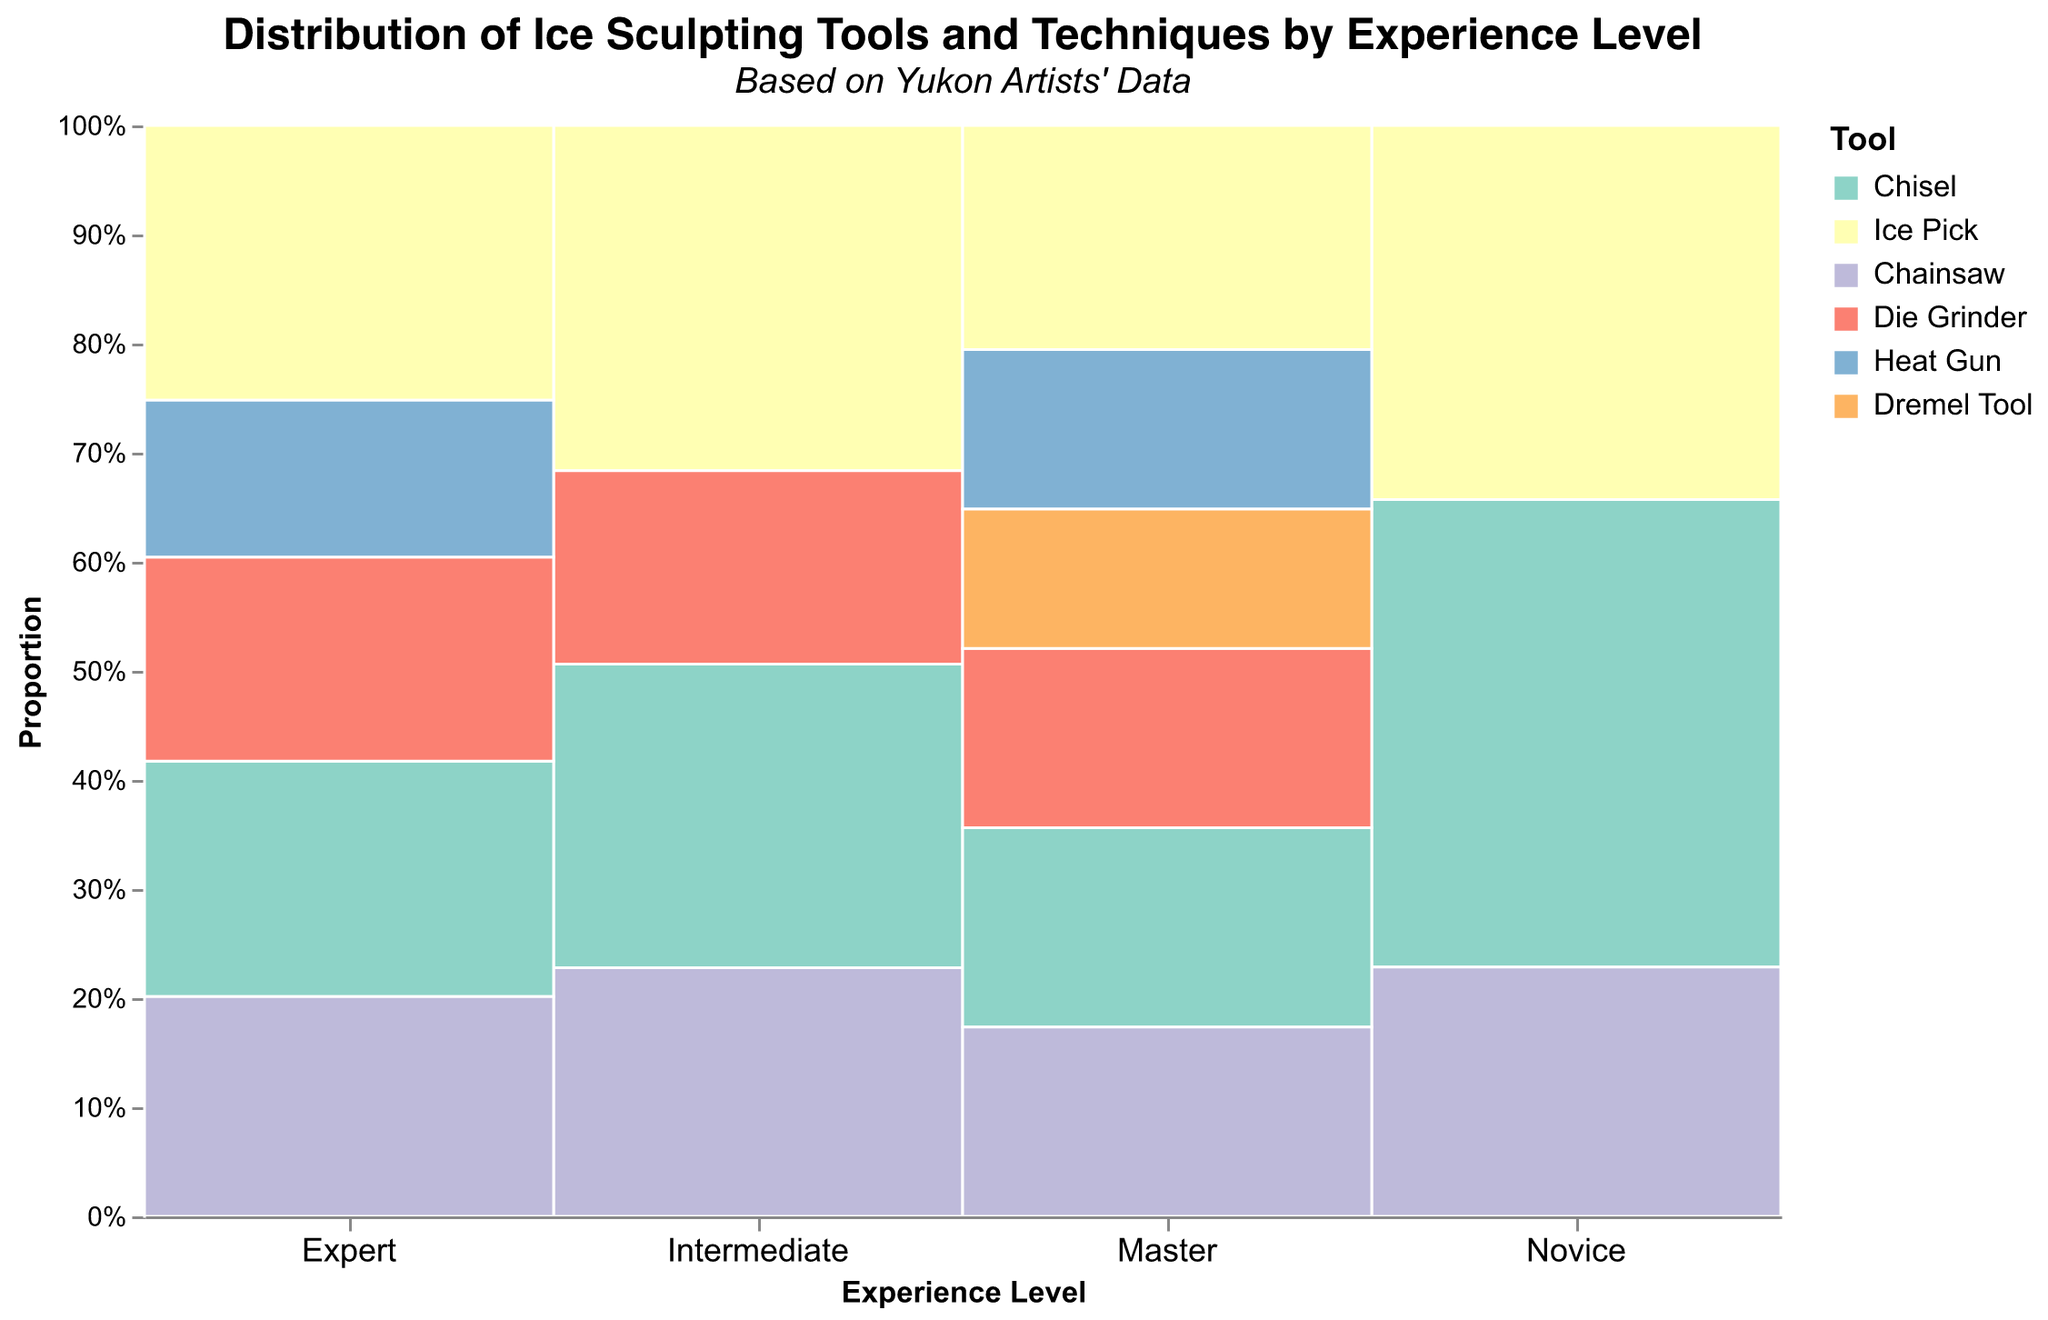What's the total count of ice sculpting tools used by experts? The bars for experts show counts of 30 (Chisel), 35 (Ice Pick), 28 (Chainsaw), 26 (Die Grinder), and 20 (Heat Gun). Summing these values gives us 30 + 35 + 28 + 26 + 20 = 139.
Answer: 139 Which experience level uses the Ice Pick for detailing the most? The Ice Pick count for each level can be observed. Master has 45, Expert has 35, Intermediate has 25, and Novice has 12. The highest count is found under Masters.
Answer: Master What proportion of tools used by novices are for rough carving with a Chisel? The total count of tools used by novices is 15 (Chisel) + 12 (Ice Pick) + 8 (Chainsaw) = 35. The Chisel count is 15. The proportion is 15/35 which is approximately 0.429 or 42.9%.
Answer: 42.9% Compare the usage of Chainsaws for block shaping between experts and masters. Experts use Chainsaws for block shaping 28 times, and masters use them 38 times. Masters use them more by a difference of 38 - 28 = 10 times.
Answer: Masters, by 10 more Which tool is unique to the Master level in the dataset? By looking at the different tools used by each experience level, the Dremel Tool appears only at the Master level.
Answer: Dremel Tool What is the most common tool for intermediate-level artists? The counts for Intermediate levels are 22 (Chisel), 25 (Ice Pick), 18 (Chainsaw), and 14 (Die Grinder). The Ice Pick has the highest count at 25.
Answer: Ice Pick What tool has a consistent increase in usage from Novice to Master levels? Observing the counts: Chisel increases from 15 (Novice), 22 (Intermediate), 30 (Expert), to 40 (Master). It consistently increases at each level.
Answer: Chisel 